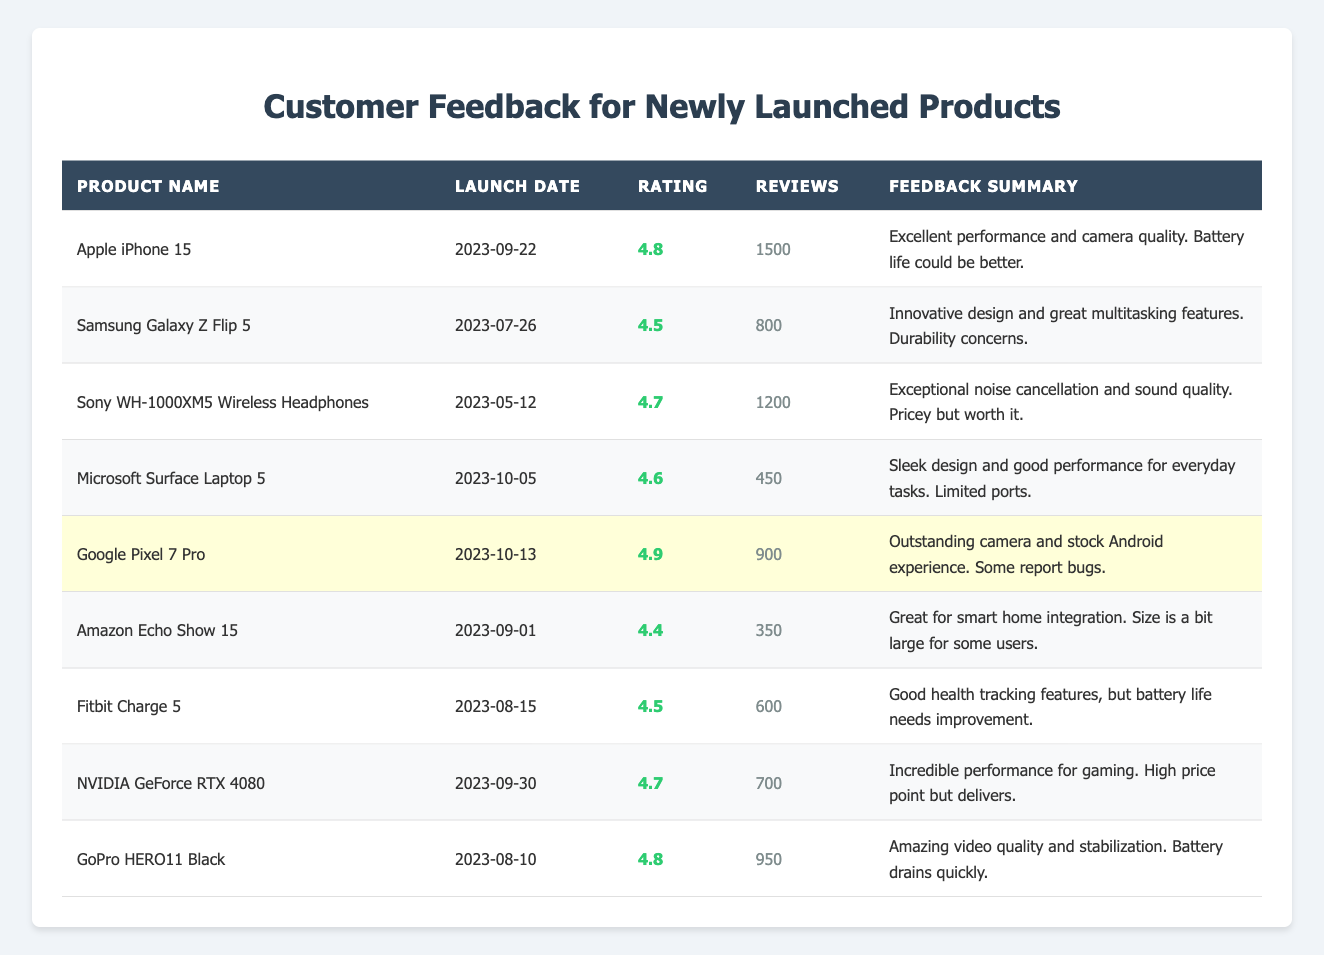What is the highest customer rating among the products? The table shows customer ratings for each product. Scanning through the ratings, the highest rating is 4.9 for the Google Pixel 7 Pro.
Answer: 4.9 How many reviews did the Sony WH-1000XM5 Wireless Headphones receive? Referring to the table, the number of reviews for the Sony WH-1000XM5 Wireless Headphones is listed as 1200.
Answer: 1200 Is the battery life of the Apple iPhone 15 ideal according to customer feedback? The feedback summary for the Apple iPhone 15 mentions that the battery life could be better, implying it is not ideal.
Answer: No What is the average customer rating of products launched before September 2023? The customer ratings for products launched before September 2023 are: 4.7 (Sony WH-1000XM5), 4.5 (Samsung Galaxy Z Flip 5), 4.4 (Amazon Echo Show 15), and 4.5 (Fitbit Charge 5). Summing these gives 4.7 + 4.5 + 4.4 + 4.5 = 18.1, and dividing by 4 gives an average of 18.1/4 = 4.525.
Answer: 4.525 How many products have a rating of 4.7 or higher? By reviewing the table, the products with ratings of 4.7 or higher are the Apple iPhone 15, Sony WH-1000XM5, Google Pixel 7 Pro, NVIDIA GeForce RTX 4080, and GoPro HERO11 Black. There are 5 such products in total.
Answer: 5 What product received the most reviews? Checking the number of reviews for each product shows that the Apple iPhone 15 has the highest number of reviews at 1500.
Answer: Apple iPhone 15 Which product has the lowest customer rating? Scanning through the ratings in the table, the lowest rating is 4.4, which belongs to the Amazon Echo Show 15.
Answer: Amazon Echo Show 15 What is the total number of reviews for all products launched in August 2023? The products launched in August 2023 are the Fitbit Charge 5 (600 reviews) and GoPro HERO11 Black (950 reviews). Adding these gives 600 + 950 = 1550 reviews in total.
Answer: 1550 Are there any products that received outstanding feedback specifically for their camera quality? The feedback summaries for the Apple iPhone 15 and Google Pixel 7 Pro highlight outstanding camera quality, indicating that both products received excellent feedback concerning this feature.
Answer: Yes What product was launched most recently, and how many reviews did it get? The Microsoft Surface Laptop 5 was launched most recently on 2023-10-05 and has received 450 reviews.
Answer: Microsoft Surface Laptop 5, 450 reviews 